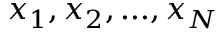<formula> <loc_0><loc_0><loc_500><loc_500>x _ { 1 } , x _ { 2 } , \dots , x _ { N }</formula> 